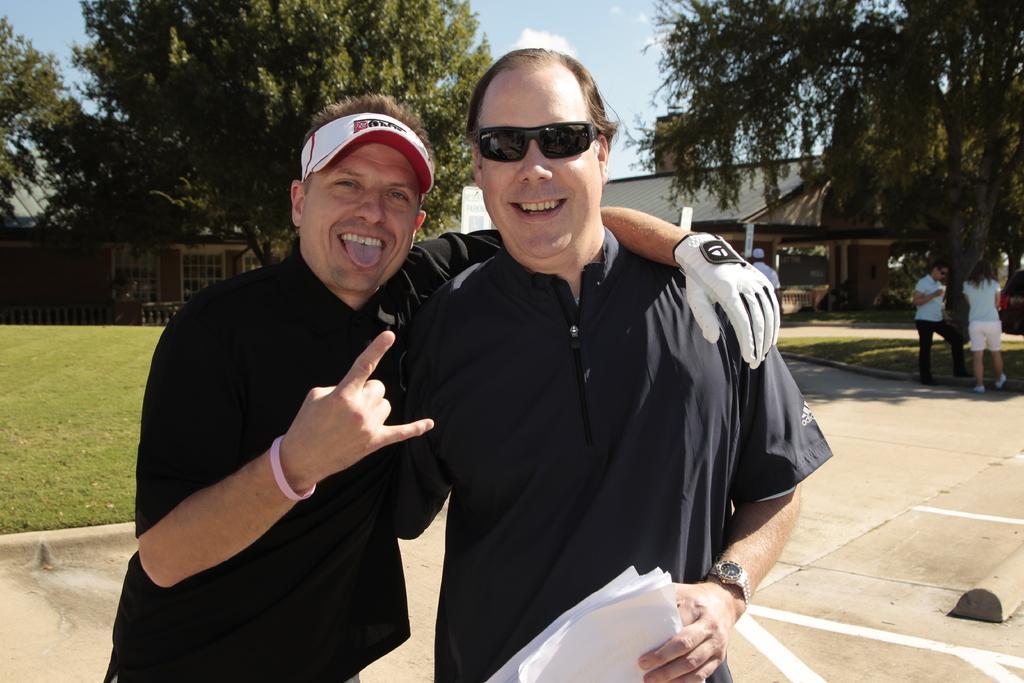Please provide a concise description of this image. This is an outside view. Here I can see two men standing, smiling and giving pose for the picture. The man who is on the right side is holding some papers in the hand. On the right side there are few people standing. In the background there are trees and a shed. On the left side, I can see the grass. At the top of the image I can see the sky. 